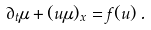Convert formula to latex. <formula><loc_0><loc_0><loc_500><loc_500>\partial _ { t } \mu + ( u \mu ) _ { x } = f ( u ) \, .</formula> 